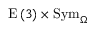Convert formula to latex. <formula><loc_0><loc_0><loc_500><loc_500>E \left ( 3 \right ) \times S y m _ { \Omega }</formula> 